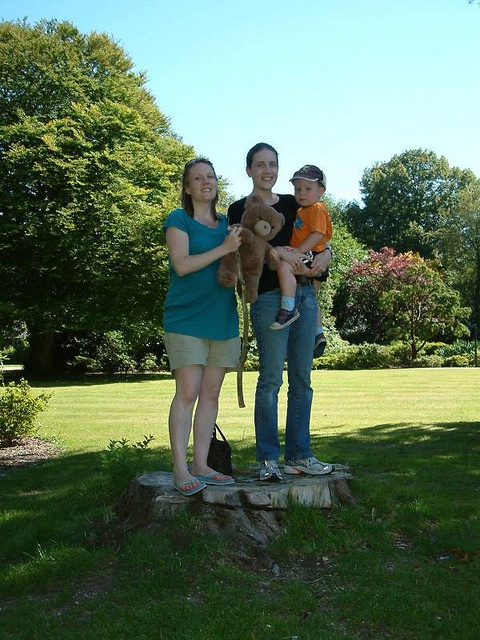Describe the objects in this image and their specific colors. I can see people in lightblue, gray, teal, black, and darkblue tones, people in lightblue, black, blue, darkblue, and gray tones, people in lightblue, gray, black, and brown tones, teddy bear in lightblue, black, and gray tones, and handbag in lightblue, black, khaki, darkgreen, and tan tones in this image. 